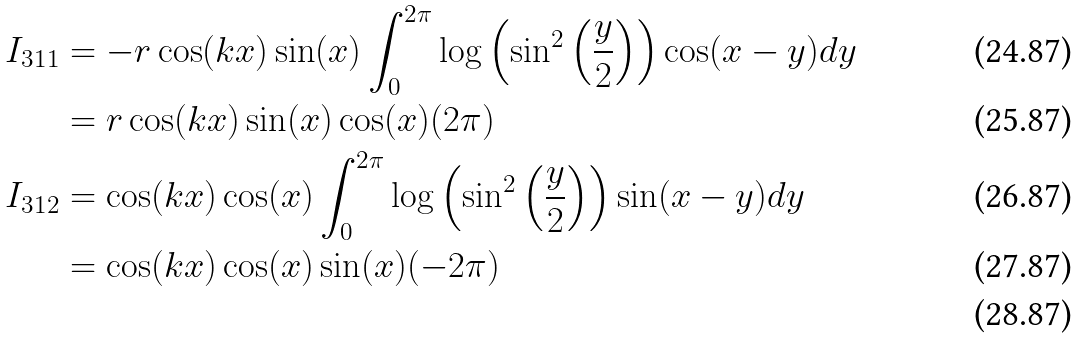<formula> <loc_0><loc_0><loc_500><loc_500>I _ { 3 1 1 } & = - r \cos ( k x ) \sin ( x ) \int _ { 0 } ^ { 2 \pi } \log \left ( \sin ^ { 2 } \left ( \frac { y } { 2 } \right ) \right ) \cos ( x - y ) d y \\ & = r \cos ( k x ) \sin ( x ) \cos ( x ) ( 2 \pi ) \\ I _ { 3 1 2 } & = \cos ( k x ) \cos ( x ) \int _ { 0 } ^ { 2 \pi } \log \left ( \sin ^ { 2 } \left ( \frac { y } { 2 } \right ) \right ) \sin ( x - y ) d y \\ & = \cos ( k x ) \cos ( x ) \sin ( x ) ( - 2 \pi ) \\</formula> 